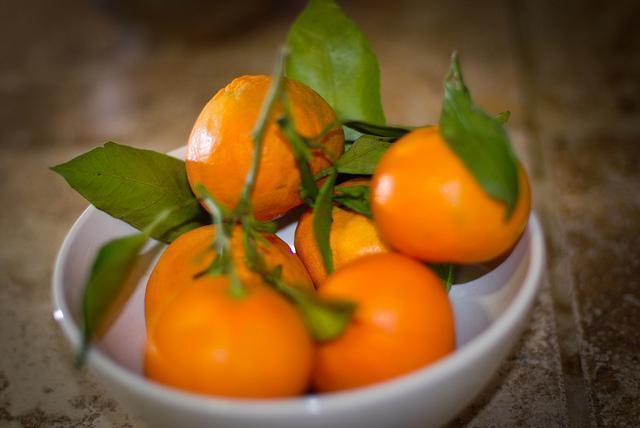How many oranges can be seen?
Give a very brief answer. 5. 